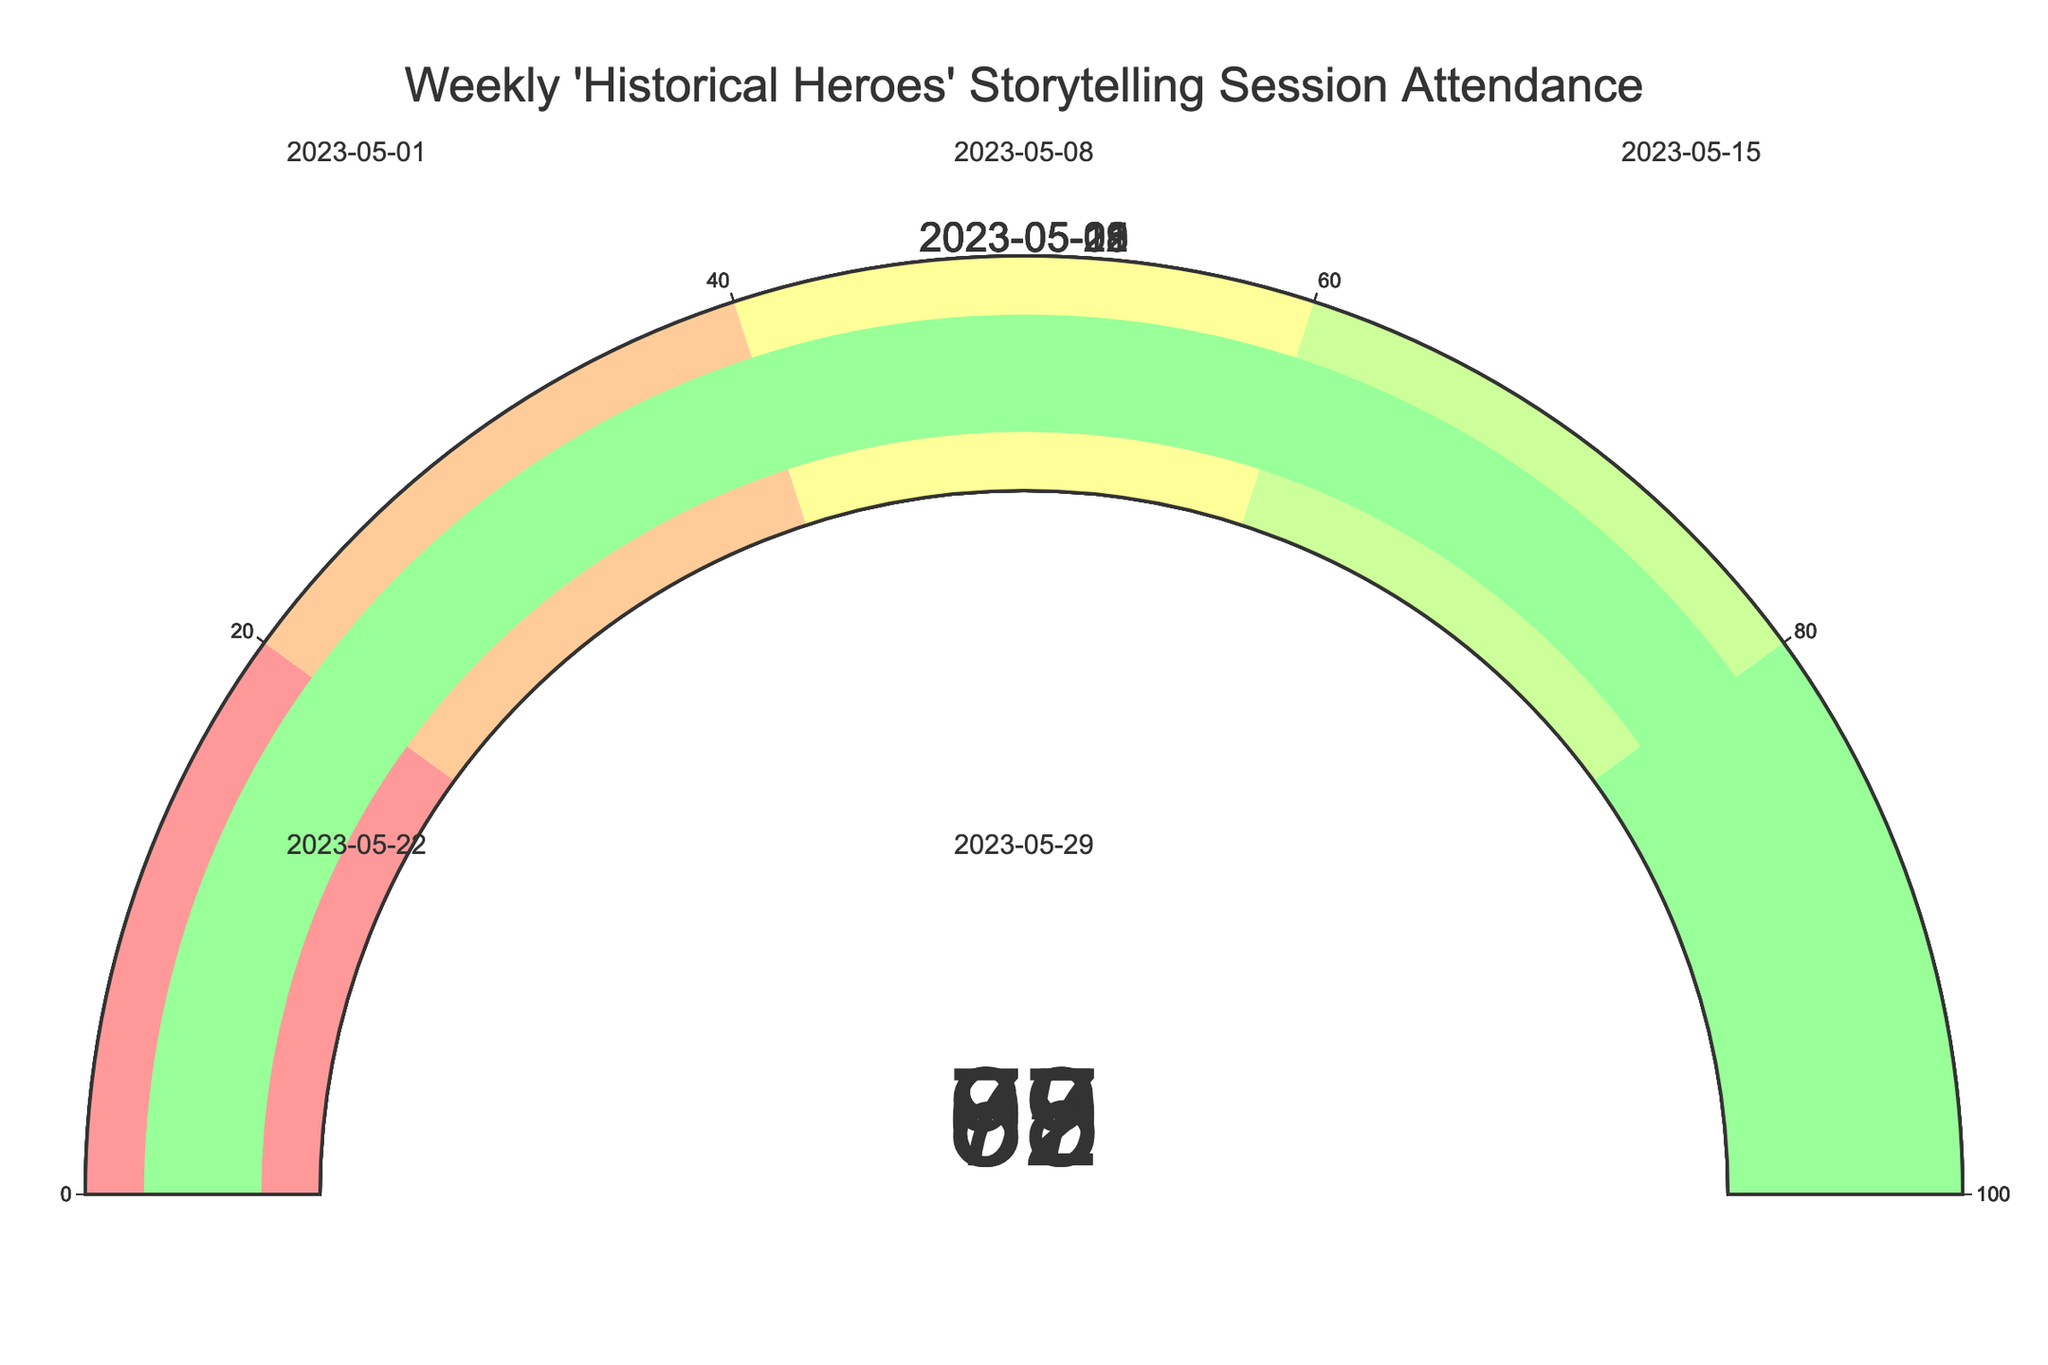What is the attendance percentage for the session held on 2023-05-15? Look for the gauge corresponding to the date 2023-05-15 and read the percentage value displayed on it.
Answer: 92% Which session had the lowest attendance percentage? Identify the gauge with the lowest percentage value by comparing all the attendance percentages displayed for each session.
Answer: The session on 2023-05-22 with 67% What is the average attendance percentage across all sessions? Add all the attendance percentages and divide by the number of sessions: (78 + 85 + 92 + 67 + 89) / 5 = 411 / 5 = 82.2
Answer: 82.2% How much higher was the attendance on 2023-05-29 compared to 2023-05-22? Subtract the attendance percentage on 2023-05-22 from the attendance percentage on 2023-05-29: 89 - 67 = 22
Answer: 22% Which session had a higher attendance, the one on 2023-05-01 or the one on 2023-05-22? Compare the attendance percentages on both dates. The percentage for 2023-05-01 is 78, and for 2023-05-22 it is 67.
Answer: The session on 2023-05-01 with 78% What was the range of attendance percentages for May? Identify the highest and lowest attendance percentages and find the difference. Highest is 92 (2023-05-15), lowest is 67 (2023-05-22). The range is 92 - 67 = 25.
Answer: 25 How many sessions had an attendance rate above 80%? Count the number of gauges with a value greater than 80%. These are 2023-05-08 (85%), 2023-05-15 (92%), and 2023-05-29 (89%).
Answer: 3 Is the attendance on 2023-05-08 greater than on 2023-05-01? Compare the attendance percentages: 85% on 2023-05-08 and 78% on 2023-05-01.
Answer: Yes What is the median attendance percentage for the sessions? List the attendance percentages in ascending order: 67, 78, 85, 89, 92. The middle value (median) is 85.
Answer: 85 